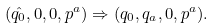Convert formula to latex. <formula><loc_0><loc_0><loc_500><loc_500>( \hat { q _ { 0 } } , 0 , 0 , p ^ { a } ) \Rightarrow ( q _ { 0 } , q _ { a } , 0 , p ^ { a } ) .</formula> 